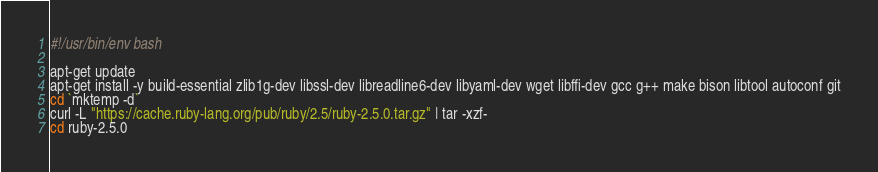<code> <loc_0><loc_0><loc_500><loc_500><_Bash_>#!/usr/bin/env bash

apt-get update
apt-get install -y build-essential zlib1g-dev libssl-dev libreadline6-dev libyaml-dev wget libffi-dev gcc g++ make bison libtool autoconf git
cd `mktemp -d`
curl -L "https://cache.ruby-lang.org/pub/ruby/2.5/ruby-2.5.0.tar.gz" | tar -xzf-
cd ruby-2.5.0</code> 